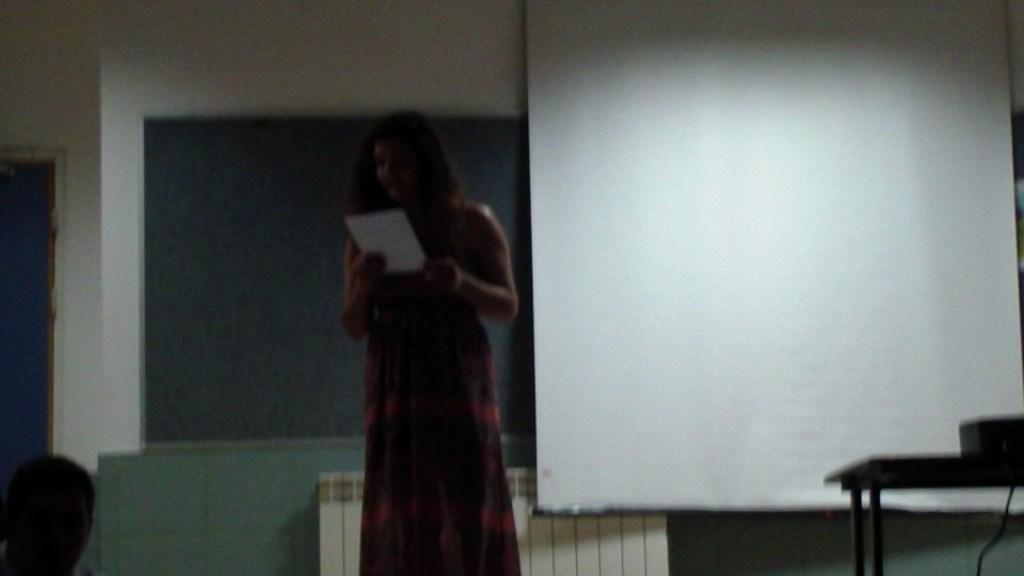How many people are in the image? There are two persons in the image. What is one of the persons holding? One of the persons is holding a paper. What can be seen on the wall in the image? There is a screen visible in the image. What is located on the table in the image? There is a projector on a table in the image. What type of drink is being served in the image? There is no drink present in the image. Is there a plough visible in the image? No, there is no plough present in the image. 